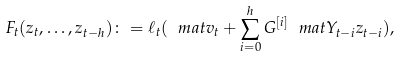<formula> <loc_0><loc_0><loc_500><loc_500>F _ { t } ( z _ { t } , \dots , z _ { t - h } ) \colon = \ell _ { t } ( \ m a t v _ { t } + \sum _ { i = 0 } ^ { h } G ^ { [ i ] } \ m a t Y _ { t - i } z _ { t - i } ) ,</formula> 